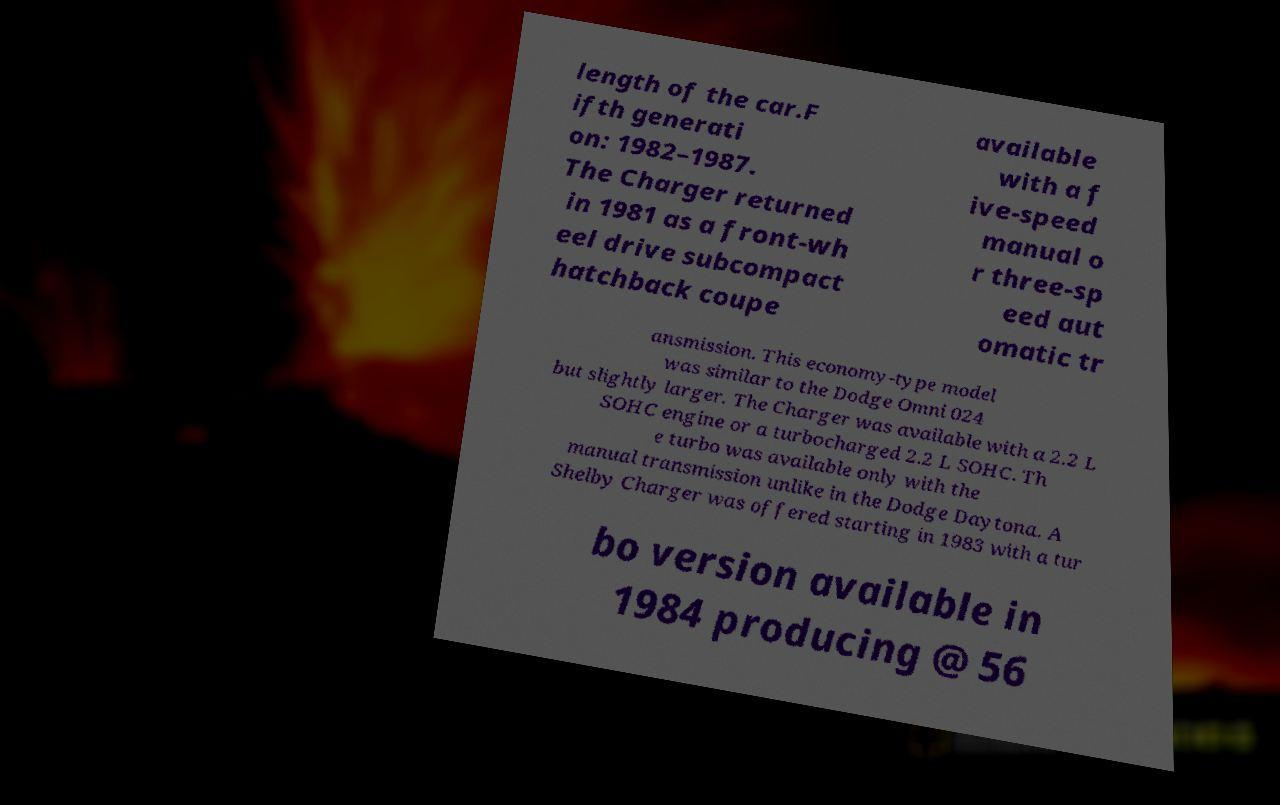I need the written content from this picture converted into text. Can you do that? length of the car.F ifth generati on: 1982–1987. The Charger returned in 1981 as a front-wh eel drive subcompact hatchback coupe available with a f ive-speed manual o r three-sp eed aut omatic tr ansmission. This economy-type model was similar to the Dodge Omni 024 but slightly larger. The Charger was available with a 2.2 L SOHC engine or a turbocharged 2.2 L SOHC. Th e turbo was available only with the manual transmission unlike in the Dodge Daytona. A Shelby Charger was offered starting in 1983 with a tur bo version available in 1984 producing @ 56 